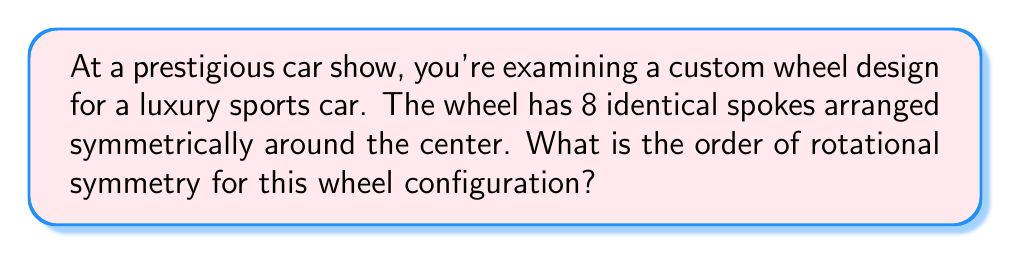Show me your answer to this math problem. To solve this problem, we need to understand the concept of rotational symmetry in the context of wheel configurations:

1. Rotational symmetry occurs when an object can be rotated around a central point and appear unchanged.

2. The order of rotational symmetry is the number of distinct rotations (including the identity rotation) that bring the object back to its original appearance.

3. For a wheel with $n$ identical spokes arranged symmetrically:
   - The smallest rotation that brings the wheel back to its original position is $\frac{360°}{n}$.
   - The order of rotational symmetry is equal to $n$.

In this case:
- The wheel has 8 identical spokes.
- The smallest rotation that brings the wheel back to its original position is $\frac{360°}{8} = 45°$.
- The wheel can be rotated by $45°$, $90°$, $135°$, $180°$, $225°$, $270°$, $315°$, and $360°$ (or $0°$) to return to its original position.

Therefore, there are 8 distinct rotations (including the identity rotation) that bring the wheel back to its original appearance.

[asy]
unitsize(1cm);
import geometry;

for(int i=0; i<8; ++i) {
  draw(rotate(45*i)*(0,0)--(4,0), linewidth(1pt));
}
draw(circle((0,0), 4), linewidth(1.5pt));
[/asy]
Answer: The order of rotational symmetry for the wheel configuration is 8. 